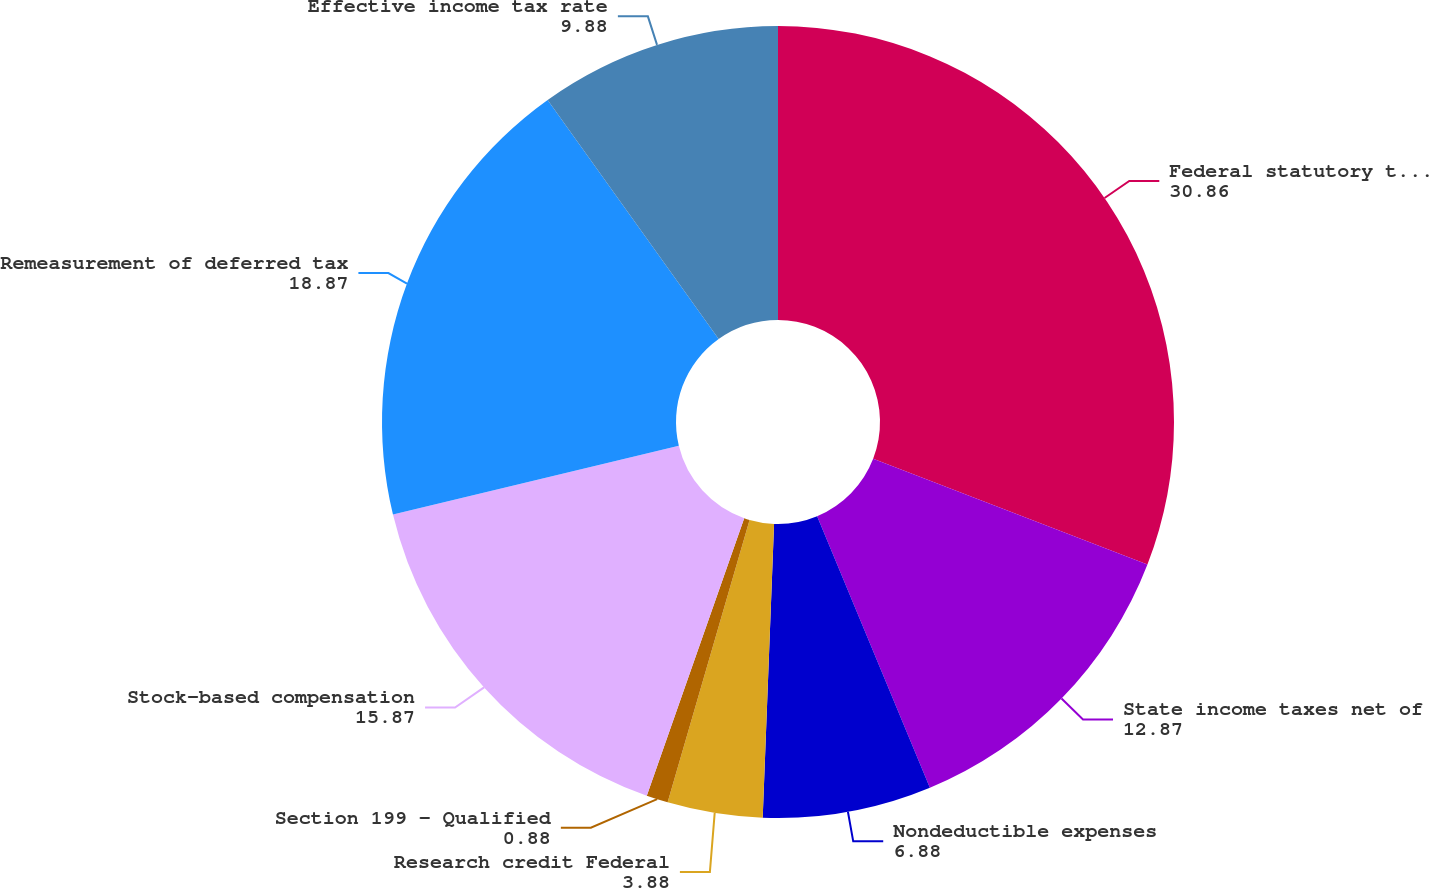<chart> <loc_0><loc_0><loc_500><loc_500><pie_chart><fcel>Federal statutory tax rate<fcel>State income taxes net of<fcel>Nondeductible expenses<fcel>Research credit Federal<fcel>Section 199 - Qualified<fcel>Stock-based compensation<fcel>Remeasurement of deferred tax<fcel>Effective income tax rate<nl><fcel>30.86%<fcel>12.87%<fcel>6.88%<fcel>3.88%<fcel>0.88%<fcel>15.87%<fcel>18.87%<fcel>9.88%<nl></chart> 